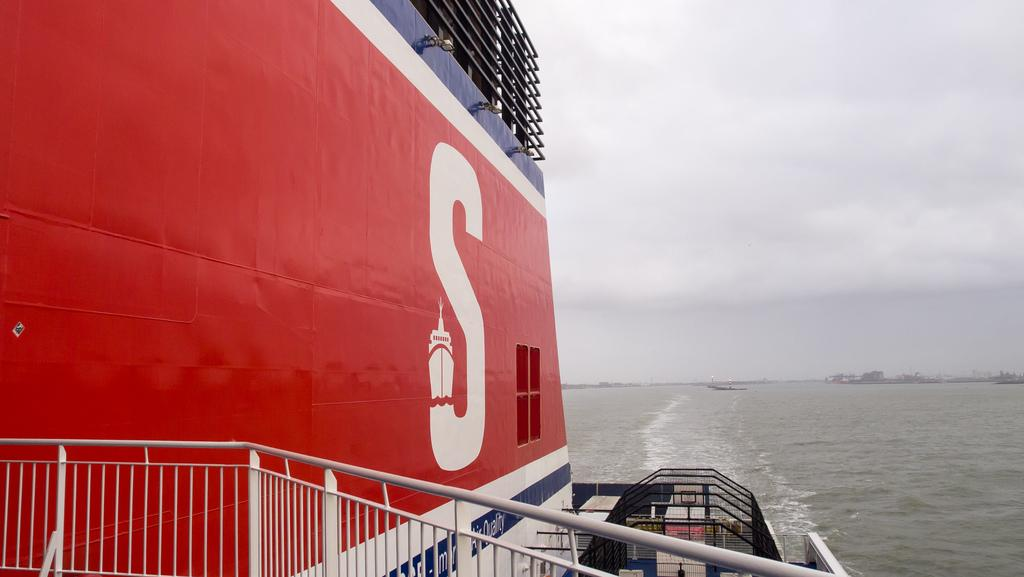What is located on the right side of the image? There is a ship on the right side of the image. What can be seen in the background of the image? There are other ships, water, and other objects visible in the background of the image. What is visible at the top of the image? The sky is visible at the top of the image. What type of ink is being used to draw the ship in the image? There is no indication that the ship in the image is drawn or painted; it appears to be a photograph or illustration of a real ship. Therefore, there is no ink present in the image. 